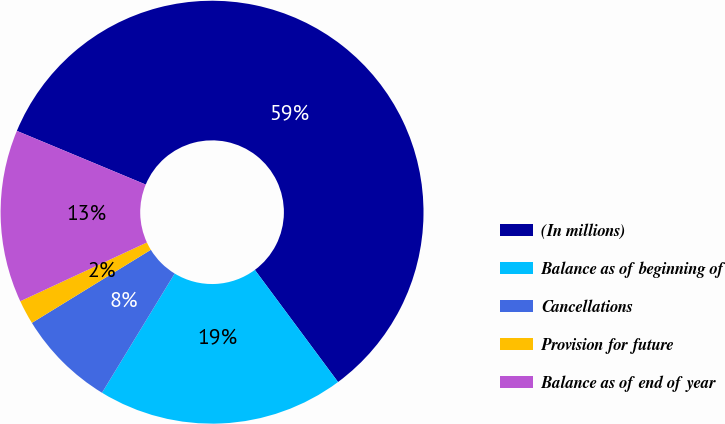Convert chart. <chart><loc_0><loc_0><loc_500><loc_500><pie_chart><fcel>(In millions)<fcel>Balance as of beginning of<fcel>Cancellations<fcel>Provision for future<fcel>Balance as of end of year<nl><fcel>58.56%<fcel>18.87%<fcel>7.52%<fcel>1.85%<fcel>13.2%<nl></chart> 